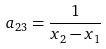<formula> <loc_0><loc_0><loc_500><loc_500>a _ { 2 3 } = \frac { 1 } { x _ { 2 } - x _ { 1 } }</formula> 